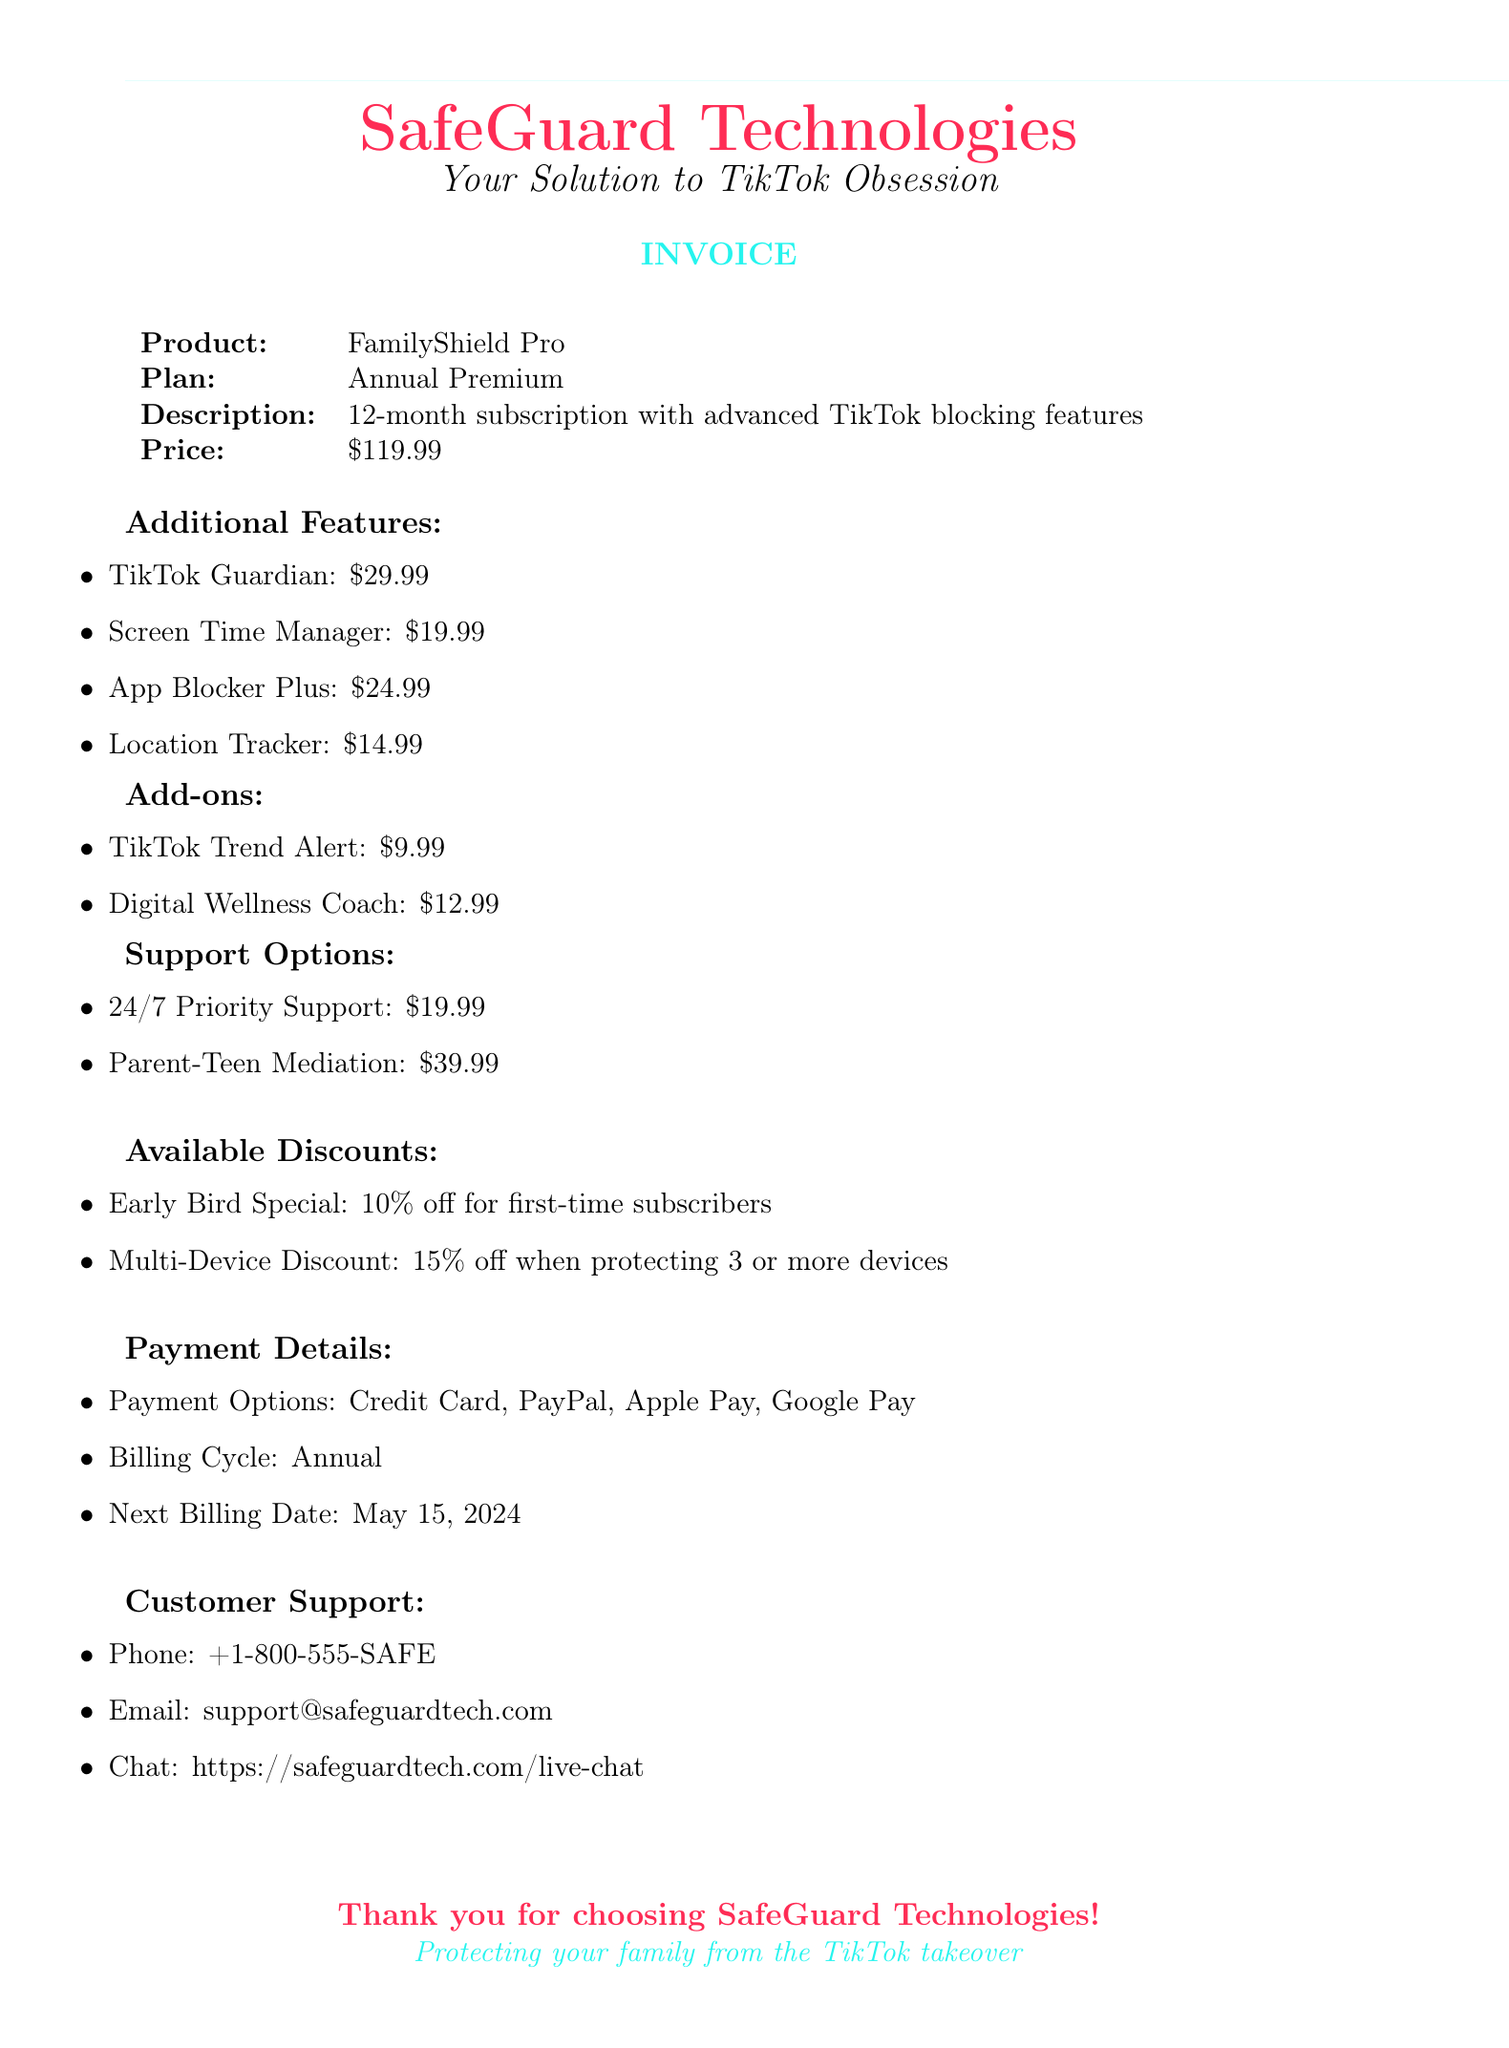what is the company name? The company name is presented at the top of the document.
Answer: SafeGuard Technologies what is the product name? The product name is listed under the product details section of the invoice.
Answer: FamilyShield Pro how much is the annual premium plan? The price for the annual premium plan is indicated in the subscription details.
Answer: $119.99 what features are offered? The features are detailed under the Additional Features section of the document.
Answer: TikTok Guardian, Screen Time Manager, App Blocker Plus, Location Tracker what discount is available for first-time subscribers? The available discount for first-time subscribers is mentioned in the Discounts section.
Answer: 10% how many support options are listed? The support options provided in the document will count the number of items listed in that section.
Answer: 2 what is the next billing date? The next billing date is specified within the payment details.
Answer: May 15, 2024 how much does the Digital Wellness Coach add-on cost? The cost for the Digital Wellness Coach is included in the add-ons section.
Answer: $12.99 what payment options are accepted? The payment options are enumerated in the Payment Details section.
Answer: Credit Card, PayPal, Apple Pay, Google Pay what is the purpose of the Parent-Teen Mediation support option? The description of the Parent-Teen Mediation indicates its purpose in the document.
Answer: Resolving conflicts over TikTok usage 